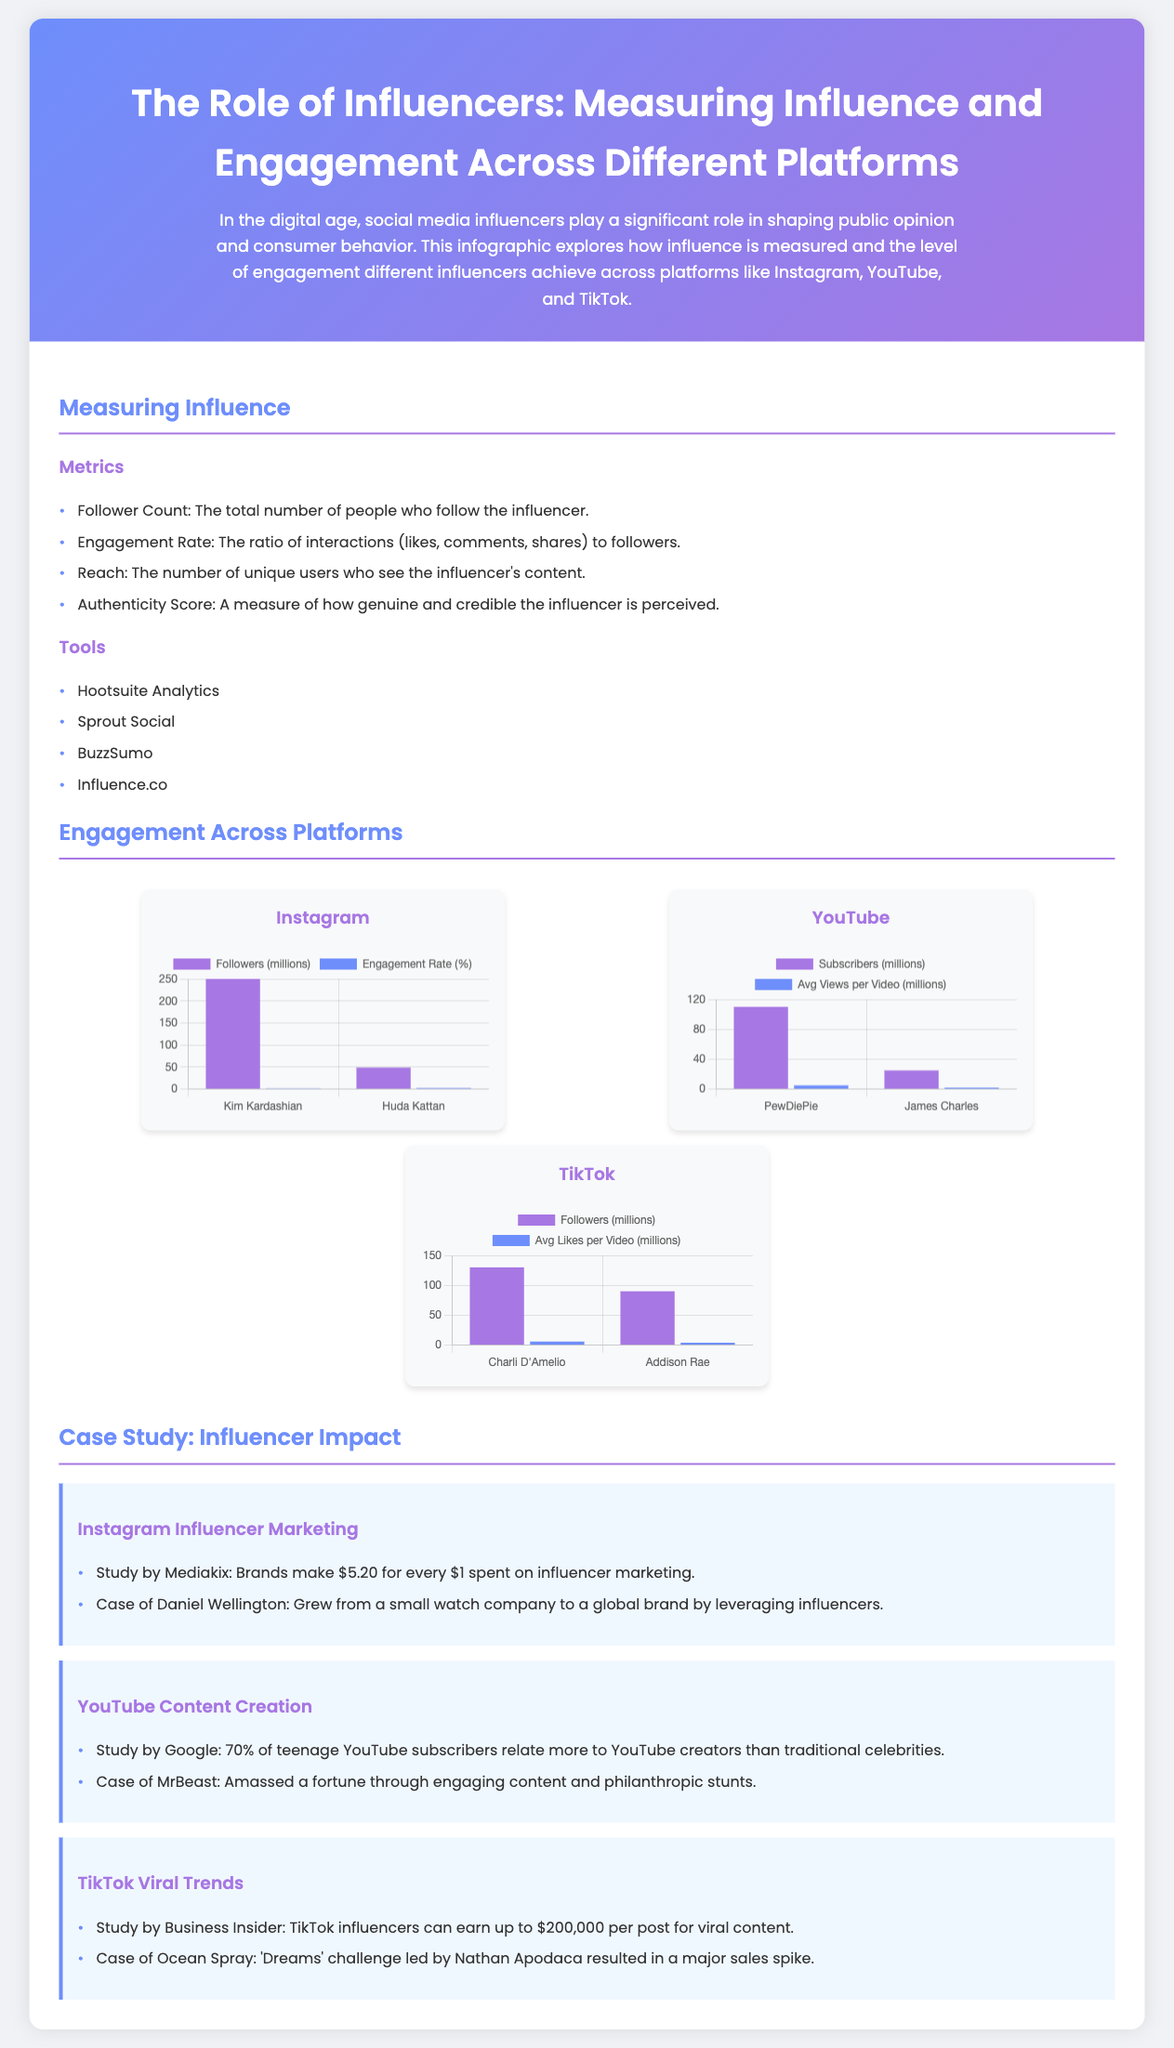What are the four metrics used to measure influence? The document lists four metrics used to measure influence: Follower Count, Engagement Rate, Reach, and Authenticity Score.
Answer: Follower Count, Engagement Rate, Reach, Authenticity Score Who are the two Instagram influencers mentioned? The document specifically names Kim Kardashian and Huda Kattan as Instagram influencers.
Answer: Kim Kardashian, Huda Kattan What is the engagement rate of Huda Kattan? The document shows that Huda Kattan has an engagement rate of 2.6%.
Answer: 2.6% How much can TikTok influencers earn per post for viral content? According to the document, TikTok influencers can earn up to $200,000 per post for viral content.
Answer: $200,000 Which YouTube influencer has the most subscribers? The document states that PewDiePie is the YouTube influencer with the most subscribers at 110 million.
Answer: PewDiePie What was the return on investment for brands in influencer marketing according to Mediakix? The infographic indicates that brands make $5.20 for every $1 spent on influencer marketing.
Answer: $5.20 What average views per video does James Charles get? The document shows that James Charles has an average of 2 million views per video.
Answer: 2 million Who had a major sales spike due to a TikTok challenge? The document mentions that Ocean Spray had a major sales spike due to the 'Dreams' challenge led by Nathan Apodaca.
Answer: Ocean Spray What is the authenticity score used for? The authenticity score is a measure of how genuine and credible the influencer is perceived.
Answer: Measuring credibility 